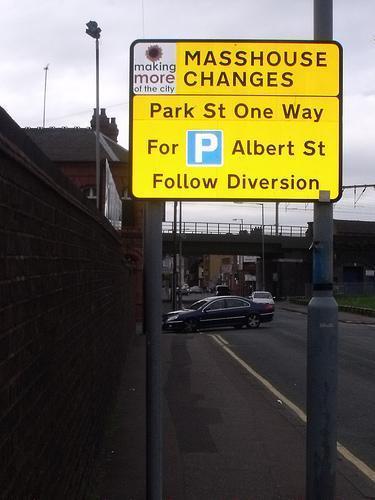How many signs are in this photo?
Give a very brief answer. 1. 